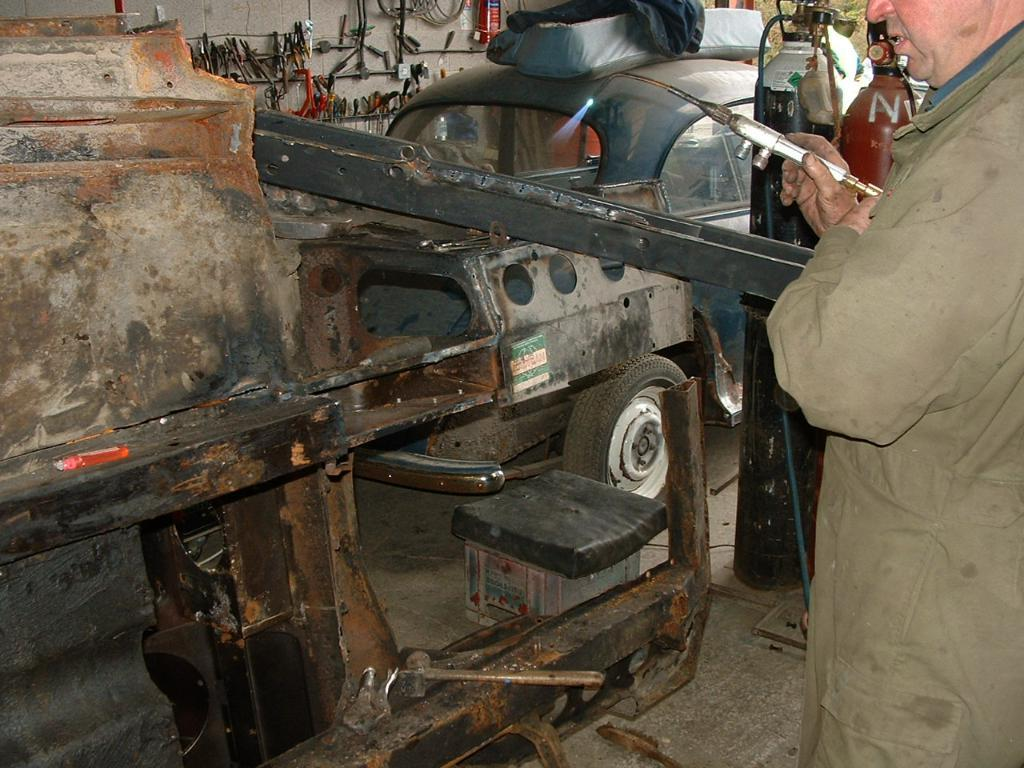What is the main subject of the image? There is a person standing in the image. What is the person holding in his hand? The person is holding an object in his hand. What can be seen in front of the person? There is a machine in front of the person. What is present on the wall in the image? There are objects hanging on the wall in the image. How many girls are sitting in the nest in the image? There is no nest or girls present in the image. What emotion does the person in the image feel about his past decisions? The image does not provide any information about the person's emotions or past decisions. 